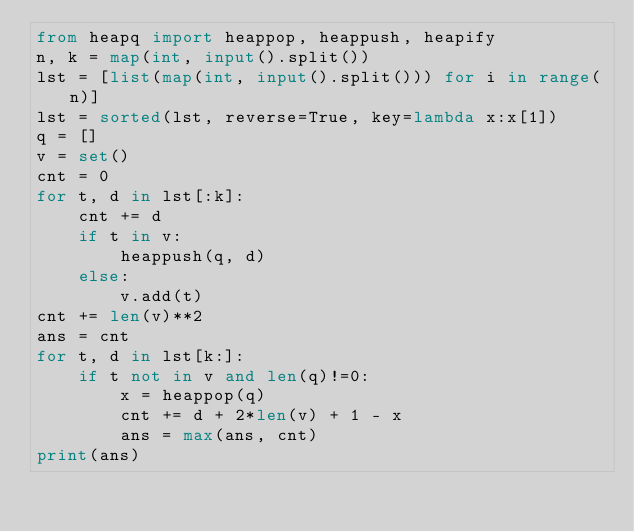<code> <loc_0><loc_0><loc_500><loc_500><_Python_>from heapq import heappop, heappush, heapify
n, k = map(int, input().split())
lst = [list(map(int, input().split())) for i in range(n)]
lst = sorted(lst, reverse=True, key=lambda x:x[1])
q = []
v = set()
cnt = 0
for t, d in lst[:k]:
    cnt += d
    if t in v:
        heappush(q, d)
    else:
        v.add(t)
cnt += len(v)**2
ans = cnt
for t, d in lst[k:]:
    if t not in v and len(q)!=0:
        x = heappop(q)
        cnt += d + 2*len(v) + 1 - x
        ans = max(ans, cnt)
print(ans)</code> 